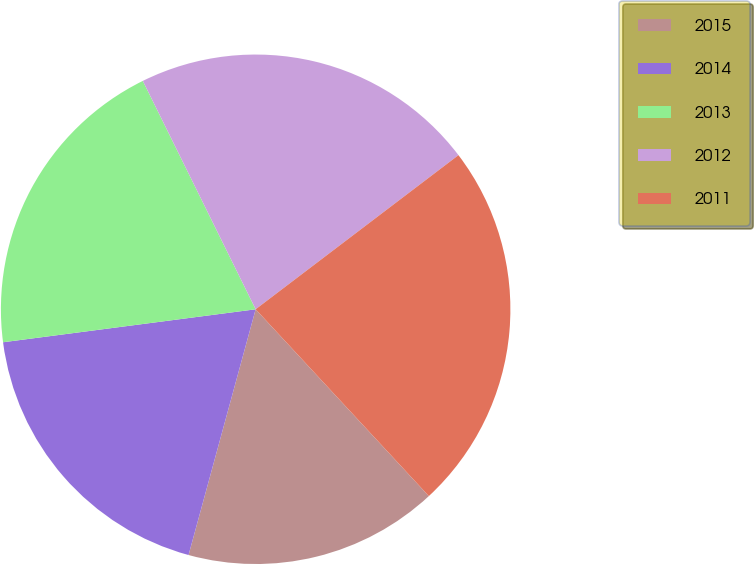Convert chart. <chart><loc_0><loc_0><loc_500><loc_500><pie_chart><fcel>2015<fcel>2014<fcel>2013<fcel>2012<fcel>2011<nl><fcel>16.14%<fcel>18.69%<fcel>19.76%<fcel>21.96%<fcel>23.44%<nl></chart> 